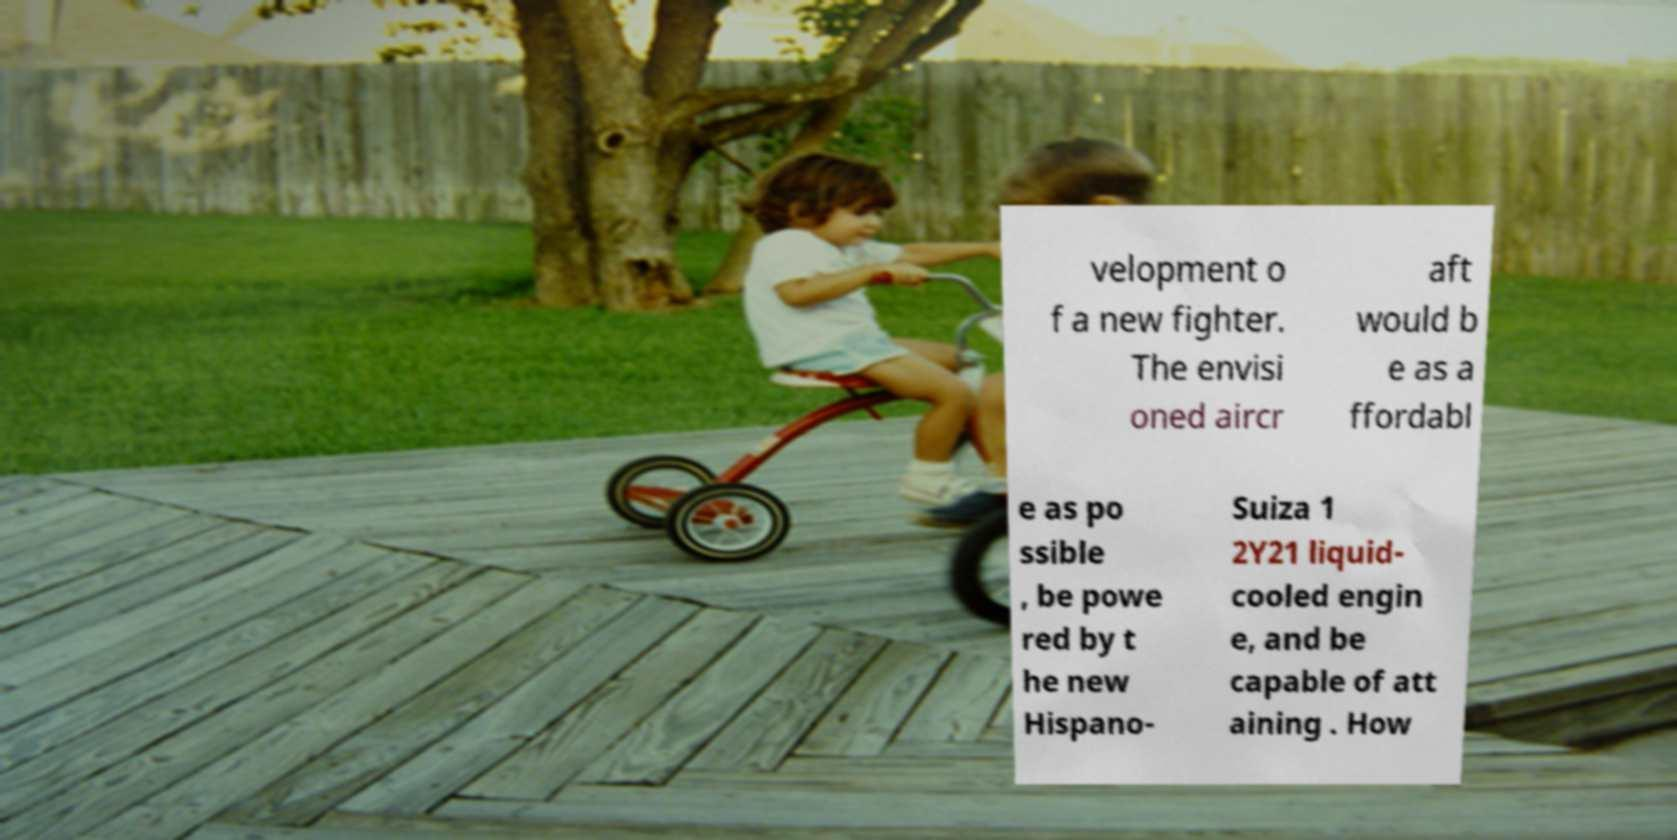Can you accurately transcribe the text from the provided image for me? velopment o f a new fighter. The envisi oned aircr aft would b e as a ffordabl e as po ssible , be powe red by t he new Hispano- Suiza 1 2Y21 liquid- cooled engin e, and be capable of att aining . How 